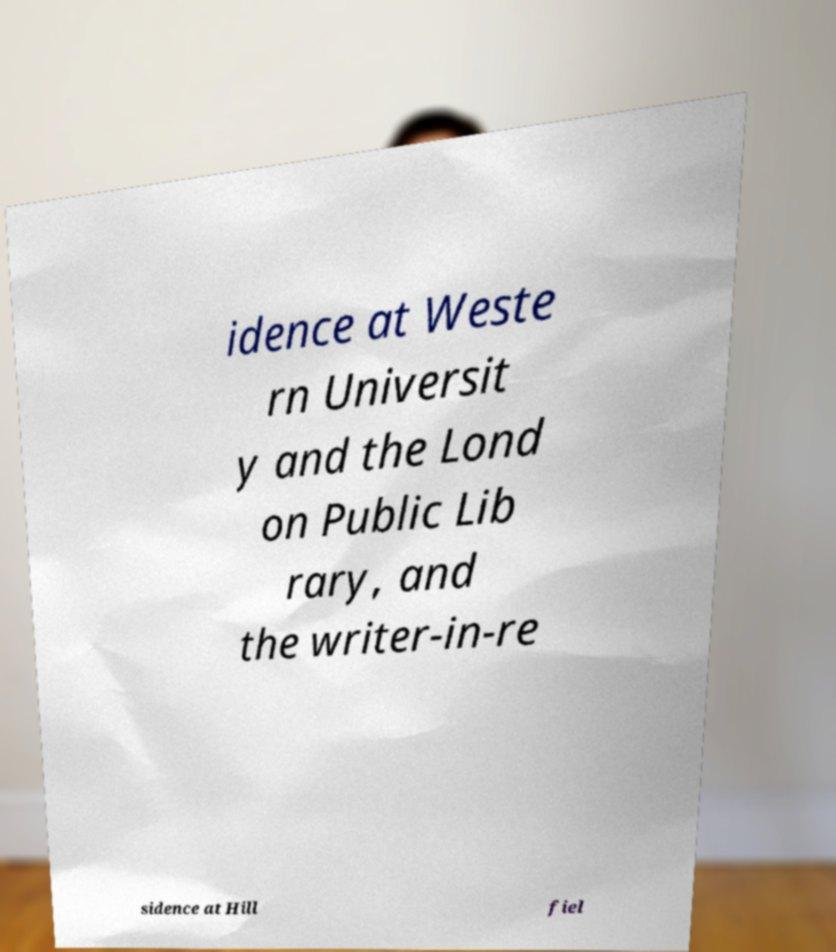Please read and relay the text visible in this image. What does it say? idence at Weste rn Universit y and the Lond on Public Lib rary, and the writer-in-re sidence at Hill fiel 